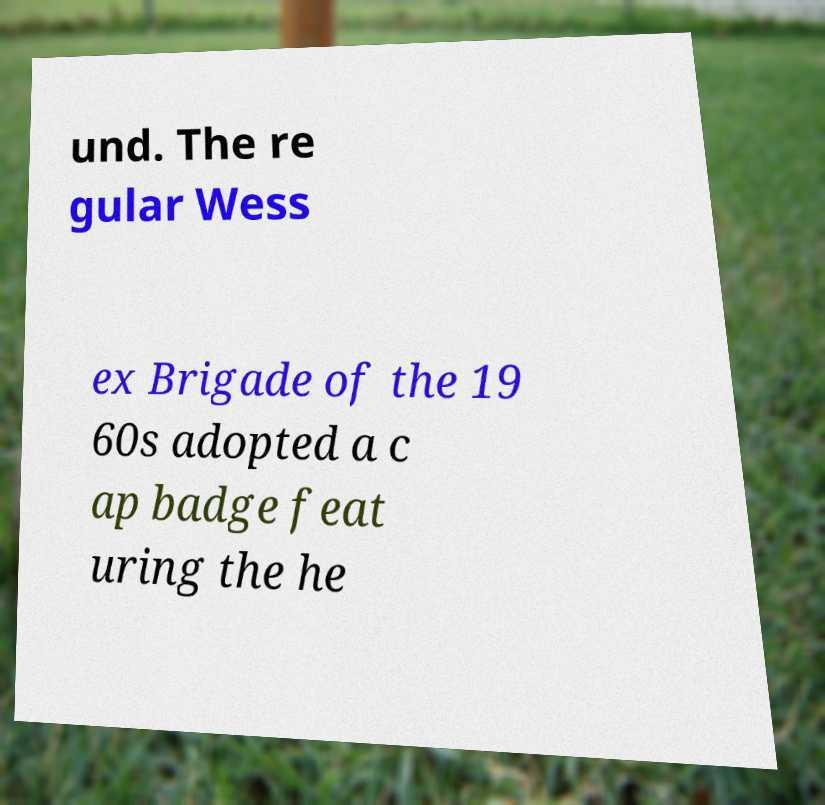Could you assist in decoding the text presented in this image and type it out clearly? und. The re gular Wess ex Brigade of the 19 60s adopted a c ap badge feat uring the he 